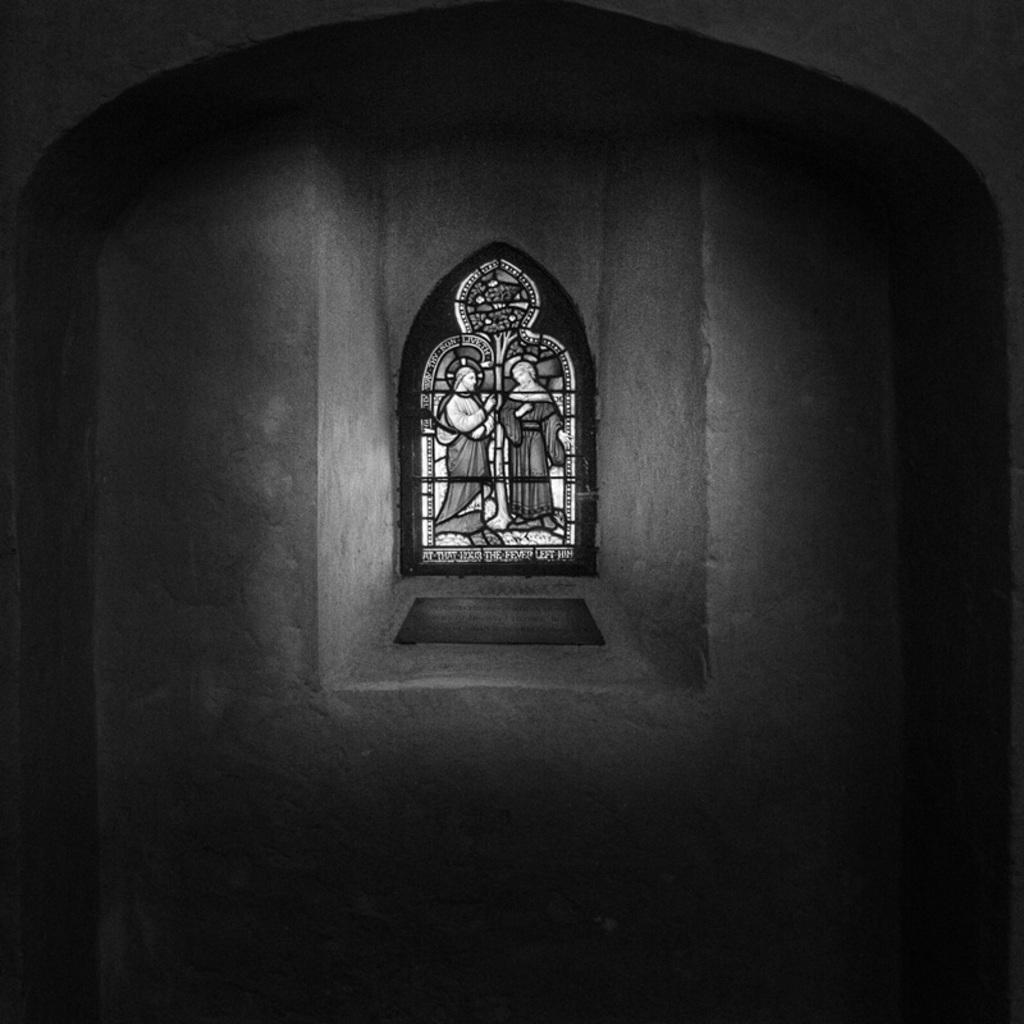What part of a building is shown in the image? The image shows the inner part of a building. What type of glass can be seen in the background of the image? There is stained glass visible in the background of the image. How many fish are swimming in the air in the image? There are no fish visible in the image. What type of magic is being performed in the image? There is no magic or any indication of a magical event in the image. 